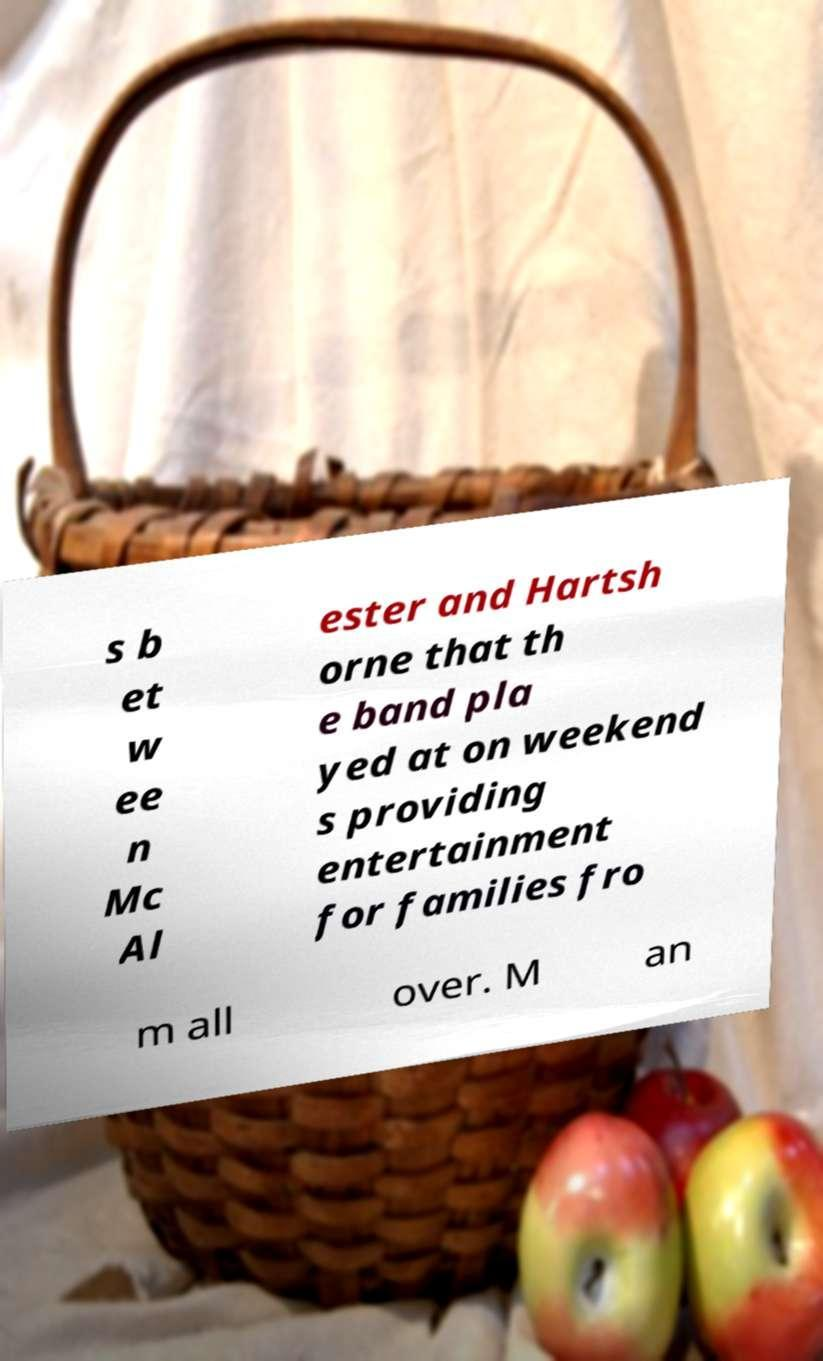Please read and relay the text visible in this image. What does it say? s b et w ee n Mc Al ester and Hartsh orne that th e band pla yed at on weekend s providing entertainment for families fro m all over. M an 